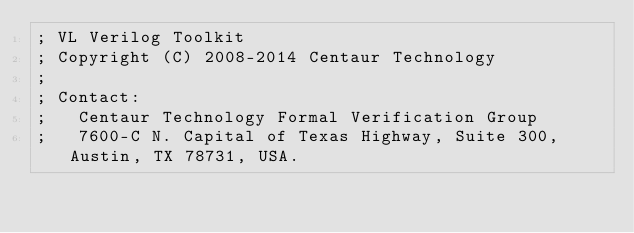Convert code to text. <code><loc_0><loc_0><loc_500><loc_500><_Lisp_>; VL Verilog Toolkit
; Copyright (C) 2008-2014 Centaur Technology
;
; Contact:
;   Centaur Technology Formal Verification Group
;   7600-C N. Capital of Texas Highway, Suite 300, Austin, TX 78731, USA.</code> 